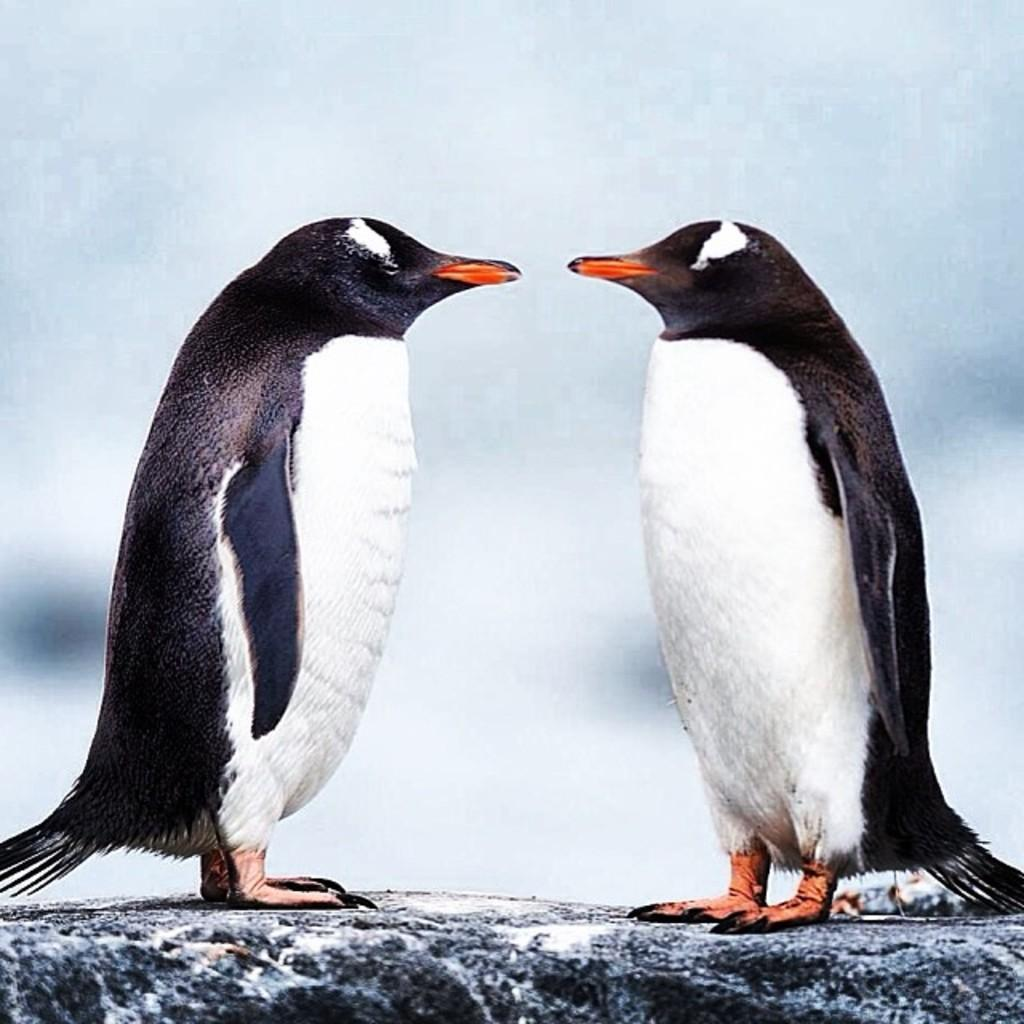What type of animals are present in the image? There are two penguins in the image. Can you describe the penguins' appearance or behavior? The provided facts do not include any information about the penguins' appearance or behavior. Are the penguins interacting with any objects or other animals in the image? The provided facts do not mention any interactions between the penguins and other objects or animals. What type of chair is the penguin sitting on in the image? There is no chair present in the image; it only features two penguins. Is the penguin holding an umbrella in the image? There is no umbrella present in the image; it only features two penguins. 